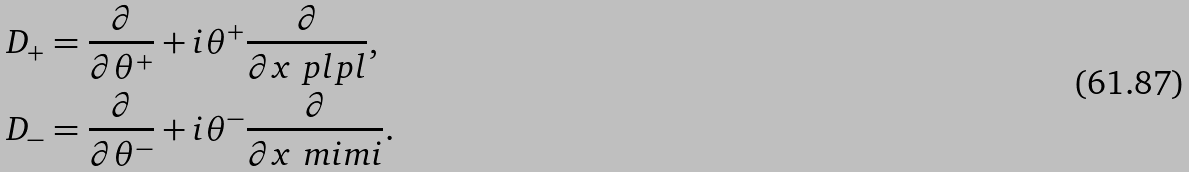Convert formula to latex. <formula><loc_0><loc_0><loc_500><loc_500>D _ { + } & = \frac { \partial } { \partial \theta ^ { + } } + i \theta ^ { + } \frac { \partial } { \partial x ^ { \ } p l p l } , \\ D _ { - } & = \frac { \partial } { \partial \theta ^ { - } } + i \theta ^ { - } \frac { \partial } { \partial x ^ { \ } m i m i } .</formula> 